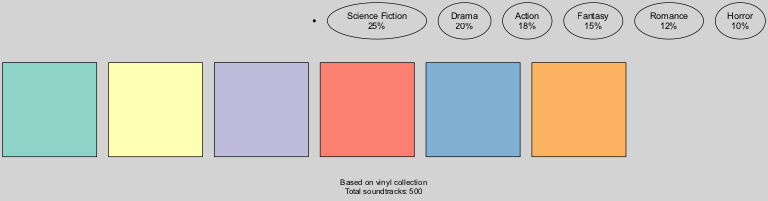What is the largest genre represented in the collection? The largest genre in the diagram is determined by comparing the percentage values for all genres. Based on the data, Science Fiction has the highest percentage at 25%. Therefore, it is the largest genre represented.
Answer: Science Fiction What percentage of soundtracks are in the Romance genre? To find the percentage for the Romance genre, we look directly at the data where Romance is listed. It shows a percentage of 12%.
Answer: 12% How many soundtracks are in the Drama genre? The total number of soundtracks in the Drama genre can be calculated by using the given total number of soundtracks (500) and applying the percentage for Drama (20%). The calculation is 500 * 0.20 = 100.
Answer: 100 Which two genres combined have the highest percentage? To answer this, we must sum the percentages of each possible pairing of genres. After evaluating combinations, Science Fiction (25%) and Drama (20%) together total 45%, which is the highest.
Answer: 45% What is the total percentage shown in the chart? The total percentage represented in the pie chart should equal 100% if all genres are accounted for. By adding the percentages from all genres (25% + 20% + 18% + 15% + 12% + 10%), we should confirm this equals 100%.
Answer: 100% What genre has the least representation in the soundtrack collection? The genre with the least representation is identified by comparing the percentage values again. Horror is listed with the lowest percentage at 10%.
Answer: Horror How many genres are represented in the soundtrack collection? To find this, we simply count the number of genre entries in the data provided. There are six genres listed: Science Fiction, Drama, Action, Fantasy, Romance, and Horror.
Answer: 6 What percentage of the soundtracks do Action and Fantasy genres represent together? Calculating the combined percentages of Action (18%) and Fantasy (15%) gives us a total of 33%. This involves a straightforward addition of the two percentages.
Answer: 33% What is the title of the chart? The title of the chart is explicitly provided in the data section. It states "Film Genres in Radio Show Soundtrack Collection."
Answer: Film Genres in Radio Show Soundtrack Collection 